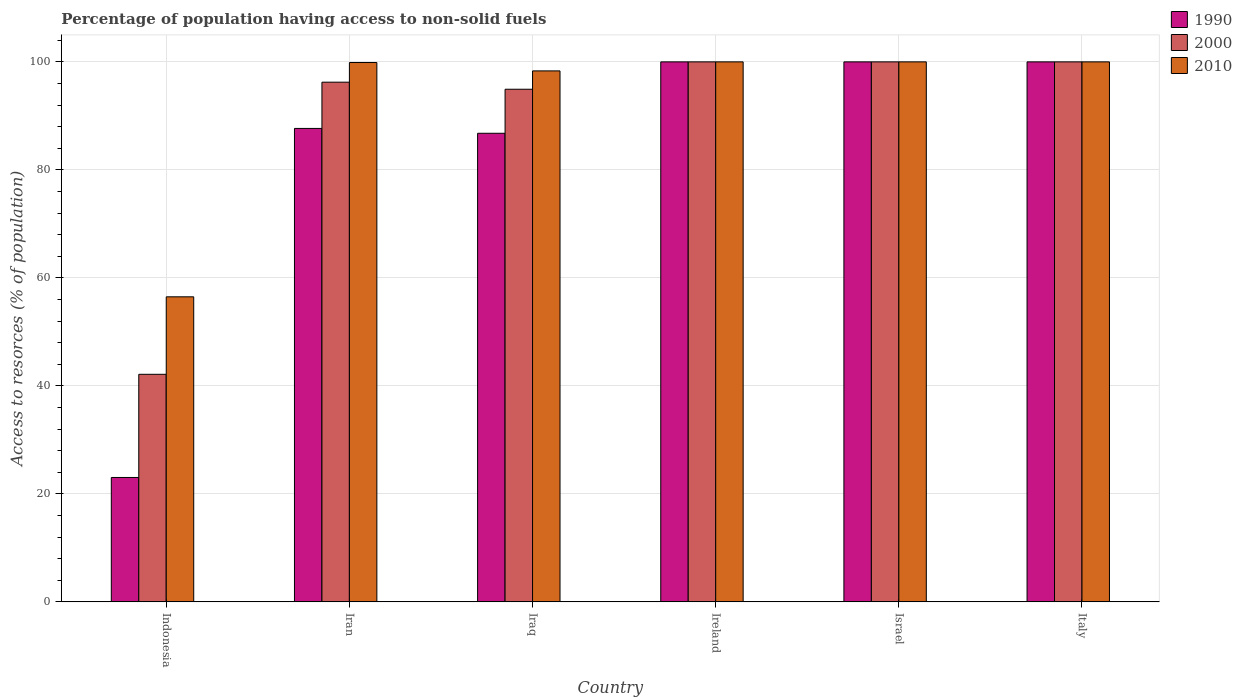How many bars are there on the 6th tick from the left?
Ensure brevity in your answer.  3. How many bars are there on the 3rd tick from the right?
Provide a short and direct response. 3. What is the label of the 2nd group of bars from the left?
Give a very brief answer. Iran. In how many cases, is the number of bars for a given country not equal to the number of legend labels?
Give a very brief answer. 0. What is the percentage of population having access to non-solid fuels in 1990 in Indonesia?
Your response must be concise. 23.04. Across all countries, what is the minimum percentage of population having access to non-solid fuels in 2010?
Your answer should be compact. 56.49. In which country was the percentage of population having access to non-solid fuels in 2010 maximum?
Make the answer very short. Ireland. In which country was the percentage of population having access to non-solid fuels in 2010 minimum?
Offer a terse response. Indonesia. What is the total percentage of population having access to non-solid fuels in 2010 in the graph?
Provide a short and direct response. 554.7. What is the difference between the percentage of population having access to non-solid fuels in 1990 in Indonesia and that in Iran?
Make the answer very short. -64.64. What is the difference between the percentage of population having access to non-solid fuels in 2000 in Israel and the percentage of population having access to non-solid fuels in 1990 in Indonesia?
Ensure brevity in your answer.  76.96. What is the average percentage of population having access to non-solid fuels in 2000 per country?
Your response must be concise. 88.89. What is the difference between the percentage of population having access to non-solid fuels of/in 2000 and percentage of population having access to non-solid fuels of/in 2010 in Iraq?
Provide a succinct answer. -3.4. In how many countries, is the percentage of population having access to non-solid fuels in 2010 greater than 44 %?
Provide a short and direct response. 6. What is the ratio of the percentage of population having access to non-solid fuels in 2000 in Iran to that in Iraq?
Keep it short and to the point. 1.01. Is the percentage of population having access to non-solid fuels in 2000 in Iraq less than that in Ireland?
Ensure brevity in your answer.  Yes. Is the difference between the percentage of population having access to non-solid fuels in 2000 in Iraq and Ireland greater than the difference between the percentage of population having access to non-solid fuels in 2010 in Iraq and Ireland?
Provide a succinct answer. No. What is the difference between the highest and the lowest percentage of population having access to non-solid fuels in 1990?
Your answer should be very brief. 76.96. In how many countries, is the percentage of population having access to non-solid fuels in 2000 greater than the average percentage of population having access to non-solid fuels in 2000 taken over all countries?
Provide a short and direct response. 5. Is the sum of the percentage of population having access to non-solid fuels in 2000 in Indonesia and Iraq greater than the maximum percentage of population having access to non-solid fuels in 2010 across all countries?
Offer a terse response. Yes. What does the 3rd bar from the left in Iraq represents?
Provide a short and direct response. 2010. What does the 2nd bar from the right in Iran represents?
Provide a succinct answer. 2000. How many bars are there?
Keep it short and to the point. 18. Are all the bars in the graph horizontal?
Your response must be concise. No. What is the difference between two consecutive major ticks on the Y-axis?
Your answer should be compact. 20. Are the values on the major ticks of Y-axis written in scientific E-notation?
Offer a terse response. No. Does the graph contain any zero values?
Ensure brevity in your answer.  No. Does the graph contain grids?
Your answer should be compact. Yes. How are the legend labels stacked?
Provide a short and direct response. Vertical. What is the title of the graph?
Keep it short and to the point. Percentage of population having access to non-solid fuels. What is the label or title of the X-axis?
Offer a terse response. Country. What is the label or title of the Y-axis?
Your answer should be very brief. Access to resorces (% of population). What is the Access to resorces (% of population) in 1990 in Indonesia?
Your response must be concise. 23.04. What is the Access to resorces (% of population) of 2000 in Indonesia?
Give a very brief answer. 42.14. What is the Access to resorces (% of population) of 2010 in Indonesia?
Provide a short and direct response. 56.49. What is the Access to resorces (% of population) in 1990 in Iran?
Provide a succinct answer. 87.68. What is the Access to resorces (% of population) in 2000 in Iran?
Your response must be concise. 96.24. What is the Access to resorces (% of population) of 2010 in Iran?
Your answer should be very brief. 99.88. What is the Access to resorces (% of population) in 1990 in Iraq?
Your answer should be very brief. 86.78. What is the Access to resorces (% of population) in 2000 in Iraq?
Offer a terse response. 94.93. What is the Access to resorces (% of population) of 2010 in Iraq?
Provide a short and direct response. 98.33. What is the Access to resorces (% of population) in 1990 in Ireland?
Provide a succinct answer. 100. What is the Access to resorces (% of population) in 2010 in Ireland?
Provide a succinct answer. 100. What is the Access to resorces (% of population) in 2000 in Israel?
Your answer should be compact. 100. What is the Access to resorces (% of population) of 2010 in Israel?
Provide a succinct answer. 100. What is the Access to resorces (% of population) in 1990 in Italy?
Your answer should be compact. 100. What is the Access to resorces (% of population) in 2010 in Italy?
Ensure brevity in your answer.  100. Across all countries, what is the maximum Access to resorces (% of population) in 1990?
Make the answer very short. 100. Across all countries, what is the maximum Access to resorces (% of population) in 2000?
Give a very brief answer. 100. Across all countries, what is the maximum Access to resorces (% of population) of 2010?
Offer a very short reply. 100. Across all countries, what is the minimum Access to resorces (% of population) in 1990?
Keep it short and to the point. 23.04. Across all countries, what is the minimum Access to resorces (% of population) in 2000?
Provide a succinct answer. 42.14. Across all countries, what is the minimum Access to resorces (% of population) of 2010?
Your answer should be very brief. 56.49. What is the total Access to resorces (% of population) in 1990 in the graph?
Keep it short and to the point. 497.49. What is the total Access to resorces (% of population) of 2000 in the graph?
Offer a very short reply. 533.31. What is the total Access to resorces (% of population) of 2010 in the graph?
Offer a very short reply. 554.7. What is the difference between the Access to resorces (% of population) in 1990 in Indonesia and that in Iran?
Make the answer very short. -64.64. What is the difference between the Access to resorces (% of population) in 2000 in Indonesia and that in Iran?
Make the answer very short. -54.1. What is the difference between the Access to resorces (% of population) of 2010 in Indonesia and that in Iran?
Keep it short and to the point. -43.39. What is the difference between the Access to resorces (% of population) in 1990 in Indonesia and that in Iraq?
Your answer should be very brief. -63.74. What is the difference between the Access to resorces (% of population) in 2000 in Indonesia and that in Iraq?
Offer a very short reply. -52.79. What is the difference between the Access to resorces (% of population) of 2010 in Indonesia and that in Iraq?
Make the answer very short. -41.84. What is the difference between the Access to resorces (% of population) in 1990 in Indonesia and that in Ireland?
Your response must be concise. -76.96. What is the difference between the Access to resorces (% of population) of 2000 in Indonesia and that in Ireland?
Provide a short and direct response. -57.86. What is the difference between the Access to resorces (% of population) of 2010 in Indonesia and that in Ireland?
Your answer should be compact. -43.51. What is the difference between the Access to resorces (% of population) of 1990 in Indonesia and that in Israel?
Provide a short and direct response. -76.96. What is the difference between the Access to resorces (% of population) in 2000 in Indonesia and that in Israel?
Your answer should be compact. -57.86. What is the difference between the Access to resorces (% of population) in 2010 in Indonesia and that in Israel?
Provide a succinct answer. -43.51. What is the difference between the Access to resorces (% of population) in 1990 in Indonesia and that in Italy?
Your answer should be compact. -76.96. What is the difference between the Access to resorces (% of population) of 2000 in Indonesia and that in Italy?
Your response must be concise. -57.86. What is the difference between the Access to resorces (% of population) of 2010 in Indonesia and that in Italy?
Provide a succinct answer. -43.51. What is the difference between the Access to resorces (% of population) of 1990 in Iran and that in Iraq?
Your answer should be compact. 0.9. What is the difference between the Access to resorces (% of population) in 2000 in Iran and that in Iraq?
Your answer should be compact. 1.31. What is the difference between the Access to resorces (% of population) of 2010 in Iran and that in Iraq?
Keep it short and to the point. 1.55. What is the difference between the Access to resorces (% of population) in 1990 in Iran and that in Ireland?
Make the answer very short. -12.32. What is the difference between the Access to resorces (% of population) in 2000 in Iran and that in Ireland?
Ensure brevity in your answer.  -3.76. What is the difference between the Access to resorces (% of population) of 2010 in Iran and that in Ireland?
Your answer should be compact. -0.12. What is the difference between the Access to resorces (% of population) in 1990 in Iran and that in Israel?
Keep it short and to the point. -12.32. What is the difference between the Access to resorces (% of population) of 2000 in Iran and that in Israel?
Give a very brief answer. -3.76. What is the difference between the Access to resorces (% of population) in 2010 in Iran and that in Israel?
Your answer should be compact. -0.12. What is the difference between the Access to resorces (% of population) of 1990 in Iran and that in Italy?
Offer a terse response. -12.32. What is the difference between the Access to resorces (% of population) of 2000 in Iran and that in Italy?
Your answer should be very brief. -3.76. What is the difference between the Access to resorces (% of population) of 2010 in Iran and that in Italy?
Ensure brevity in your answer.  -0.12. What is the difference between the Access to resorces (% of population) in 1990 in Iraq and that in Ireland?
Provide a short and direct response. -13.22. What is the difference between the Access to resorces (% of population) of 2000 in Iraq and that in Ireland?
Keep it short and to the point. -5.07. What is the difference between the Access to resorces (% of population) in 2010 in Iraq and that in Ireland?
Give a very brief answer. -1.67. What is the difference between the Access to resorces (% of population) in 1990 in Iraq and that in Israel?
Make the answer very short. -13.22. What is the difference between the Access to resorces (% of population) of 2000 in Iraq and that in Israel?
Provide a short and direct response. -5.07. What is the difference between the Access to resorces (% of population) in 2010 in Iraq and that in Israel?
Provide a short and direct response. -1.67. What is the difference between the Access to resorces (% of population) of 1990 in Iraq and that in Italy?
Offer a terse response. -13.22. What is the difference between the Access to resorces (% of population) in 2000 in Iraq and that in Italy?
Your answer should be very brief. -5.07. What is the difference between the Access to resorces (% of population) in 2010 in Iraq and that in Italy?
Your answer should be very brief. -1.67. What is the difference between the Access to resorces (% of population) of 1990 in Ireland and that in Israel?
Your answer should be compact. 0. What is the difference between the Access to resorces (% of population) in 2010 in Ireland and that in Israel?
Offer a very short reply. 0. What is the difference between the Access to resorces (% of population) in 2000 in Ireland and that in Italy?
Your answer should be compact. 0. What is the difference between the Access to resorces (% of population) in 2010 in Ireland and that in Italy?
Provide a succinct answer. 0. What is the difference between the Access to resorces (% of population) in 2000 in Israel and that in Italy?
Keep it short and to the point. 0. What is the difference between the Access to resorces (% of population) in 1990 in Indonesia and the Access to resorces (% of population) in 2000 in Iran?
Your response must be concise. -73.2. What is the difference between the Access to resorces (% of population) in 1990 in Indonesia and the Access to resorces (% of population) in 2010 in Iran?
Offer a very short reply. -76.84. What is the difference between the Access to resorces (% of population) in 2000 in Indonesia and the Access to resorces (% of population) in 2010 in Iran?
Make the answer very short. -57.74. What is the difference between the Access to resorces (% of population) in 1990 in Indonesia and the Access to resorces (% of population) in 2000 in Iraq?
Offer a terse response. -71.9. What is the difference between the Access to resorces (% of population) in 1990 in Indonesia and the Access to resorces (% of population) in 2010 in Iraq?
Provide a short and direct response. -75.29. What is the difference between the Access to resorces (% of population) of 2000 in Indonesia and the Access to resorces (% of population) of 2010 in Iraq?
Make the answer very short. -56.19. What is the difference between the Access to resorces (% of population) of 1990 in Indonesia and the Access to resorces (% of population) of 2000 in Ireland?
Keep it short and to the point. -76.96. What is the difference between the Access to resorces (% of population) of 1990 in Indonesia and the Access to resorces (% of population) of 2010 in Ireland?
Keep it short and to the point. -76.96. What is the difference between the Access to resorces (% of population) of 2000 in Indonesia and the Access to resorces (% of population) of 2010 in Ireland?
Keep it short and to the point. -57.86. What is the difference between the Access to resorces (% of population) of 1990 in Indonesia and the Access to resorces (% of population) of 2000 in Israel?
Make the answer very short. -76.96. What is the difference between the Access to resorces (% of population) in 1990 in Indonesia and the Access to resorces (% of population) in 2010 in Israel?
Offer a terse response. -76.96. What is the difference between the Access to resorces (% of population) of 2000 in Indonesia and the Access to resorces (% of population) of 2010 in Israel?
Offer a terse response. -57.86. What is the difference between the Access to resorces (% of population) in 1990 in Indonesia and the Access to resorces (% of population) in 2000 in Italy?
Your answer should be very brief. -76.96. What is the difference between the Access to resorces (% of population) in 1990 in Indonesia and the Access to resorces (% of population) in 2010 in Italy?
Your response must be concise. -76.96. What is the difference between the Access to resorces (% of population) of 2000 in Indonesia and the Access to resorces (% of population) of 2010 in Italy?
Offer a terse response. -57.86. What is the difference between the Access to resorces (% of population) of 1990 in Iran and the Access to resorces (% of population) of 2000 in Iraq?
Provide a succinct answer. -7.26. What is the difference between the Access to resorces (% of population) of 1990 in Iran and the Access to resorces (% of population) of 2010 in Iraq?
Give a very brief answer. -10.65. What is the difference between the Access to resorces (% of population) of 2000 in Iran and the Access to resorces (% of population) of 2010 in Iraq?
Ensure brevity in your answer.  -2.09. What is the difference between the Access to resorces (% of population) in 1990 in Iran and the Access to resorces (% of population) in 2000 in Ireland?
Keep it short and to the point. -12.32. What is the difference between the Access to resorces (% of population) of 1990 in Iran and the Access to resorces (% of population) of 2010 in Ireland?
Ensure brevity in your answer.  -12.32. What is the difference between the Access to resorces (% of population) in 2000 in Iran and the Access to resorces (% of population) in 2010 in Ireland?
Give a very brief answer. -3.76. What is the difference between the Access to resorces (% of population) in 1990 in Iran and the Access to resorces (% of population) in 2000 in Israel?
Provide a succinct answer. -12.32. What is the difference between the Access to resorces (% of population) of 1990 in Iran and the Access to resorces (% of population) of 2010 in Israel?
Your response must be concise. -12.32. What is the difference between the Access to resorces (% of population) of 2000 in Iran and the Access to resorces (% of population) of 2010 in Israel?
Your answer should be very brief. -3.76. What is the difference between the Access to resorces (% of population) in 1990 in Iran and the Access to resorces (% of population) in 2000 in Italy?
Make the answer very short. -12.32. What is the difference between the Access to resorces (% of population) in 1990 in Iran and the Access to resorces (% of population) in 2010 in Italy?
Offer a very short reply. -12.32. What is the difference between the Access to resorces (% of population) in 2000 in Iran and the Access to resorces (% of population) in 2010 in Italy?
Your answer should be compact. -3.76. What is the difference between the Access to resorces (% of population) of 1990 in Iraq and the Access to resorces (% of population) of 2000 in Ireland?
Give a very brief answer. -13.22. What is the difference between the Access to resorces (% of population) of 1990 in Iraq and the Access to resorces (% of population) of 2010 in Ireland?
Offer a terse response. -13.22. What is the difference between the Access to resorces (% of population) in 2000 in Iraq and the Access to resorces (% of population) in 2010 in Ireland?
Provide a succinct answer. -5.07. What is the difference between the Access to resorces (% of population) of 1990 in Iraq and the Access to resorces (% of population) of 2000 in Israel?
Make the answer very short. -13.22. What is the difference between the Access to resorces (% of population) of 1990 in Iraq and the Access to resorces (% of population) of 2010 in Israel?
Keep it short and to the point. -13.22. What is the difference between the Access to resorces (% of population) in 2000 in Iraq and the Access to resorces (% of population) in 2010 in Israel?
Offer a terse response. -5.07. What is the difference between the Access to resorces (% of population) of 1990 in Iraq and the Access to resorces (% of population) of 2000 in Italy?
Keep it short and to the point. -13.22. What is the difference between the Access to resorces (% of population) of 1990 in Iraq and the Access to resorces (% of population) of 2010 in Italy?
Your answer should be very brief. -13.22. What is the difference between the Access to resorces (% of population) in 2000 in Iraq and the Access to resorces (% of population) in 2010 in Italy?
Offer a very short reply. -5.07. What is the difference between the Access to resorces (% of population) of 1990 in Ireland and the Access to resorces (% of population) of 2010 in Israel?
Provide a short and direct response. 0. What is the difference between the Access to resorces (% of population) of 2000 in Ireland and the Access to resorces (% of population) of 2010 in Israel?
Provide a short and direct response. 0. What is the average Access to resorces (% of population) of 1990 per country?
Provide a succinct answer. 82.92. What is the average Access to resorces (% of population) in 2000 per country?
Give a very brief answer. 88.89. What is the average Access to resorces (% of population) in 2010 per country?
Your answer should be compact. 92.45. What is the difference between the Access to resorces (% of population) of 1990 and Access to resorces (% of population) of 2000 in Indonesia?
Ensure brevity in your answer.  -19.11. What is the difference between the Access to resorces (% of population) in 1990 and Access to resorces (% of population) in 2010 in Indonesia?
Give a very brief answer. -33.46. What is the difference between the Access to resorces (% of population) of 2000 and Access to resorces (% of population) of 2010 in Indonesia?
Offer a terse response. -14.35. What is the difference between the Access to resorces (% of population) of 1990 and Access to resorces (% of population) of 2000 in Iran?
Give a very brief answer. -8.57. What is the difference between the Access to resorces (% of population) in 1990 and Access to resorces (% of population) in 2010 in Iran?
Your answer should be compact. -12.2. What is the difference between the Access to resorces (% of population) in 2000 and Access to resorces (% of population) in 2010 in Iran?
Your response must be concise. -3.64. What is the difference between the Access to resorces (% of population) of 1990 and Access to resorces (% of population) of 2000 in Iraq?
Your answer should be compact. -8.15. What is the difference between the Access to resorces (% of population) in 1990 and Access to resorces (% of population) in 2010 in Iraq?
Give a very brief answer. -11.55. What is the difference between the Access to resorces (% of population) in 2000 and Access to resorces (% of population) in 2010 in Iraq?
Ensure brevity in your answer.  -3.4. What is the difference between the Access to resorces (% of population) of 1990 and Access to resorces (% of population) of 2000 in Ireland?
Your answer should be compact. 0. What is the difference between the Access to resorces (% of population) of 1990 and Access to resorces (% of population) of 2010 in Ireland?
Give a very brief answer. 0. What is the difference between the Access to resorces (% of population) in 2000 and Access to resorces (% of population) in 2010 in Ireland?
Offer a terse response. 0. What is the difference between the Access to resorces (% of population) in 1990 and Access to resorces (% of population) in 2000 in Israel?
Make the answer very short. 0. What is the difference between the Access to resorces (% of population) in 2000 and Access to resorces (% of population) in 2010 in Israel?
Your response must be concise. 0. What is the difference between the Access to resorces (% of population) of 1990 and Access to resorces (% of population) of 2000 in Italy?
Provide a succinct answer. 0. What is the difference between the Access to resorces (% of population) of 1990 and Access to resorces (% of population) of 2010 in Italy?
Offer a very short reply. 0. What is the ratio of the Access to resorces (% of population) in 1990 in Indonesia to that in Iran?
Ensure brevity in your answer.  0.26. What is the ratio of the Access to resorces (% of population) of 2000 in Indonesia to that in Iran?
Offer a terse response. 0.44. What is the ratio of the Access to resorces (% of population) of 2010 in Indonesia to that in Iran?
Your response must be concise. 0.57. What is the ratio of the Access to resorces (% of population) in 1990 in Indonesia to that in Iraq?
Offer a terse response. 0.27. What is the ratio of the Access to resorces (% of population) in 2000 in Indonesia to that in Iraq?
Give a very brief answer. 0.44. What is the ratio of the Access to resorces (% of population) of 2010 in Indonesia to that in Iraq?
Your answer should be compact. 0.57. What is the ratio of the Access to resorces (% of population) of 1990 in Indonesia to that in Ireland?
Ensure brevity in your answer.  0.23. What is the ratio of the Access to resorces (% of population) in 2000 in Indonesia to that in Ireland?
Your answer should be very brief. 0.42. What is the ratio of the Access to resorces (% of population) of 2010 in Indonesia to that in Ireland?
Provide a short and direct response. 0.56. What is the ratio of the Access to resorces (% of population) in 1990 in Indonesia to that in Israel?
Provide a short and direct response. 0.23. What is the ratio of the Access to resorces (% of population) in 2000 in Indonesia to that in Israel?
Ensure brevity in your answer.  0.42. What is the ratio of the Access to resorces (% of population) of 2010 in Indonesia to that in Israel?
Your response must be concise. 0.56. What is the ratio of the Access to resorces (% of population) of 1990 in Indonesia to that in Italy?
Provide a succinct answer. 0.23. What is the ratio of the Access to resorces (% of population) in 2000 in Indonesia to that in Italy?
Provide a short and direct response. 0.42. What is the ratio of the Access to resorces (% of population) in 2010 in Indonesia to that in Italy?
Ensure brevity in your answer.  0.56. What is the ratio of the Access to resorces (% of population) of 1990 in Iran to that in Iraq?
Provide a succinct answer. 1.01. What is the ratio of the Access to resorces (% of population) in 2000 in Iran to that in Iraq?
Your response must be concise. 1.01. What is the ratio of the Access to resorces (% of population) of 2010 in Iran to that in Iraq?
Make the answer very short. 1.02. What is the ratio of the Access to resorces (% of population) of 1990 in Iran to that in Ireland?
Provide a short and direct response. 0.88. What is the ratio of the Access to resorces (% of population) in 2000 in Iran to that in Ireland?
Your answer should be very brief. 0.96. What is the ratio of the Access to resorces (% of population) of 1990 in Iran to that in Israel?
Your response must be concise. 0.88. What is the ratio of the Access to resorces (% of population) of 2000 in Iran to that in Israel?
Your response must be concise. 0.96. What is the ratio of the Access to resorces (% of population) of 2010 in Iran to that in Israel?
Your response must be concise. 1. What is the ratio of the Access to resorces (% of population) in 1990 in Iran to that in Italy?
Ensure brevity in your answer.  0.88. What is the ratio of the Access to resorces (% of population) of 2000 in Iran to that in Italy?
Your answer should be compact. 0.96. What is the ratio of the Access to resorces (% of population) in 2010 in Iran to that in Italy?
Your answer should be very brief. 1. What is the ratio of the Access to resorces (% of population) in 1990 in Iraq to that in Ireland?
Give a very brief answer. 0.87. What is the ratio of the Access to resorces (% of population) in 2000 in Iraq to that in Ireland?
Your answer should be very brief. 0.95. What is the ratio of the Access to resorces (% of population) in 2010 in Iraq to that in Ireland?
Your response must be concise. 0.98. What is the ratio of the Access to resorces (% of population) in 1990 in Iraq to that in Israel?
Your answer should be compact. 0.87. What is the ratio of the Access to resorces (% of population) in 2000 in Iraq to that in Israel?
Make the answer very short. 0.95. What is the ratio of the Access to resorces (% of population) in 2010 in Iraq to that in Israel?
Keep it short and to the point. 0.98. What is the ratio of the Access to resorces (% of population) in 1990 in Iraq to that in Italy?
Provide a succinct answer. 0.87. What is the ratio of the Access to resorces (% of population) of 2000 in Iraq to that in Italy?
Provide a short and direct response. 0.95. What is the ratio of the Access to resorces (% of population) in 2010 in Iraq to that in Italy?
Ensure brevity in your answer.  0.98. What is the ratio of the Access to resorces (% of population) of 2000 in Ireland to that in Israel?
Offer a terse response. 1. What is the ratio of the Access to resorces (% of population) in 2010 in Ireland to that in Italy?
Offer a terse response. 1. What is the ratio of the Access to resorces (% of population) of 1990 in Israel to that in Italy?
Make the answer very short. 1. What is the ratio of the Access to resorces (% of population) in 2000 in Israel to that in Italy?
Make the answer very short. 1. What is the ratio of the Access to resorces (% of population) of 2010 in Israel to that in Italy?
Keep it short and to the point. 1. What is the difference between the highest and the second highest Access to resorces (% of population) of 1990?
Offer a very short reply. 0. What is the difference between the highest and the second highest Access to resorces (% of population) of 2000?
Make the answer very short. 0. What is the difference between the highest and the second highest Access to resorces (% of population) in 2010?
Offer a very short reply. 0. What is the difference between the highest and the lowest Access to resorces (% of population) in 1990?
Your response must be concise. 76.96. What is the difference between the highest and the lowest Access to resorces (% of population) in 2000?
Give a very brief answer. 57.86. What is the difference between the highest and the lowest Access to resorces (% of population) of 2010?
Your response must be concise. 43.51. 